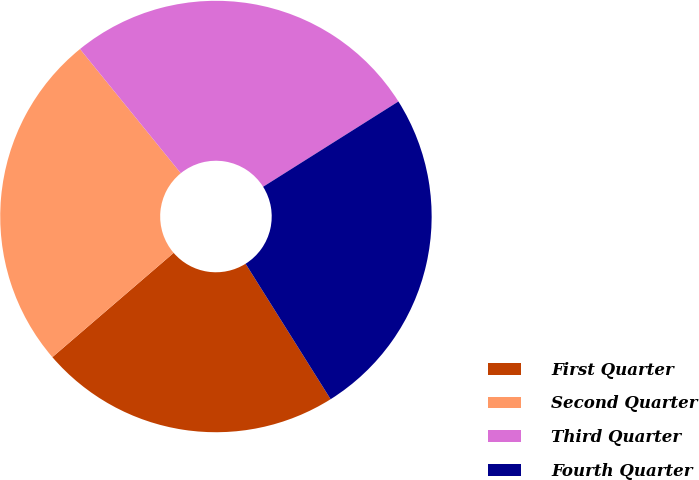<chart> <loc_0><loc_0><loc_500><loc_500><pie_chart><fcel>First Quarter<fcel>Second Quarter<fcel>Third Quarter<fcel>Fourth Quarter<nl><fcel>22.62%<fcel>25.45%<fcel>26.9%<fcel>25.03%<nl></chart> 